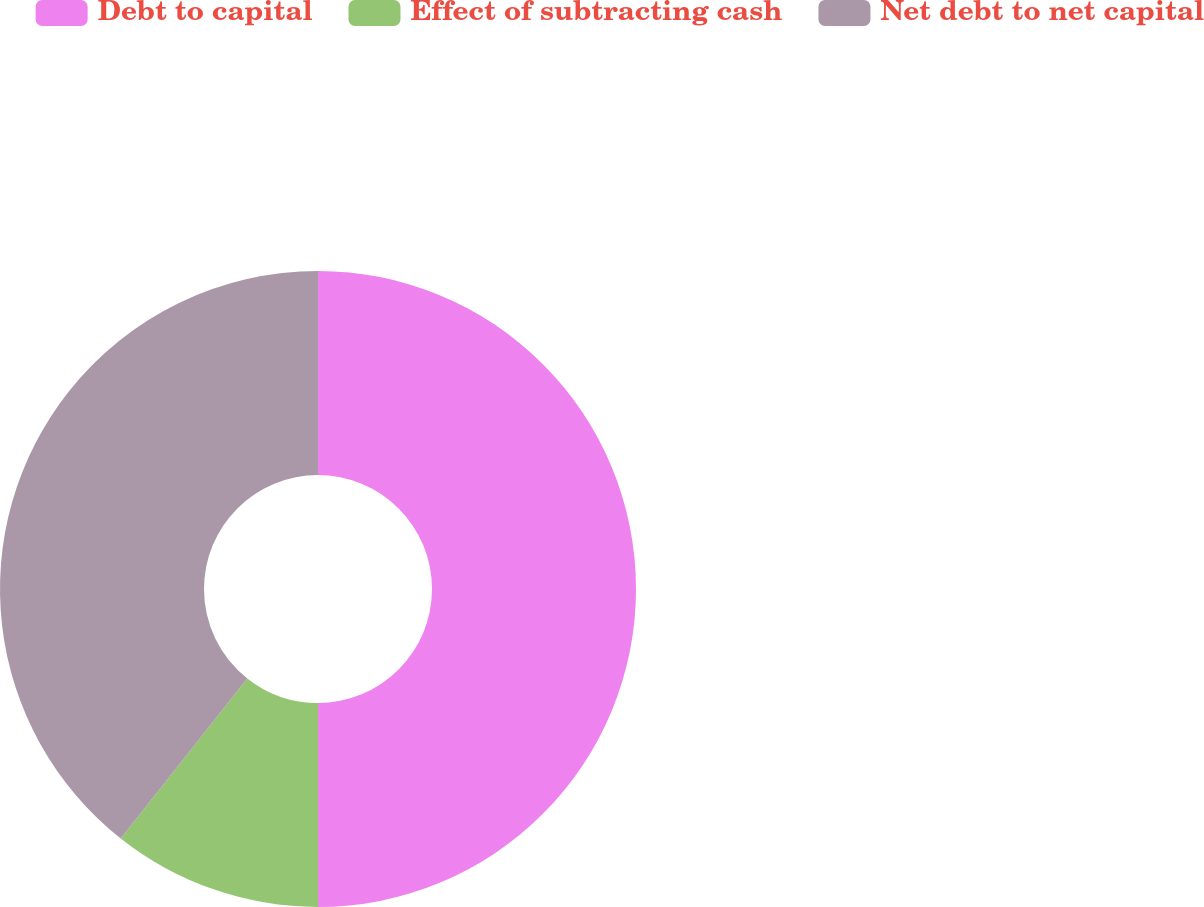Convert chart. <chart><loc_0><loc_0><loc_500><loc_500><pie_chart><fcel>Debt to capital<fcel>Effect of subtracting cash<fcel>Net debt to net capital<nl><fcel>50.0%<fcel>10.65%<fcel>39.35%<nl></chart> 